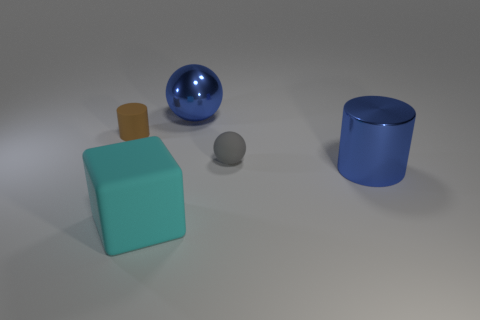Add 3 gray rubber objects. How many objects exist? 8 Subtract all purple cylinders. Subtract all purple blocks. How many cylinders are left? 2 Subtract all blocks. How many objects are left? 4 Subtract all small green cubes. Subtract all matte balls. How many objects are left? 4 Add 2 small gray objects. How many small gray objects are left? 3 Add 1 large cyan blocks. How many large cyan blocks exist? 2 Subtract 1 cyan cubes. How many objects are left? 4 